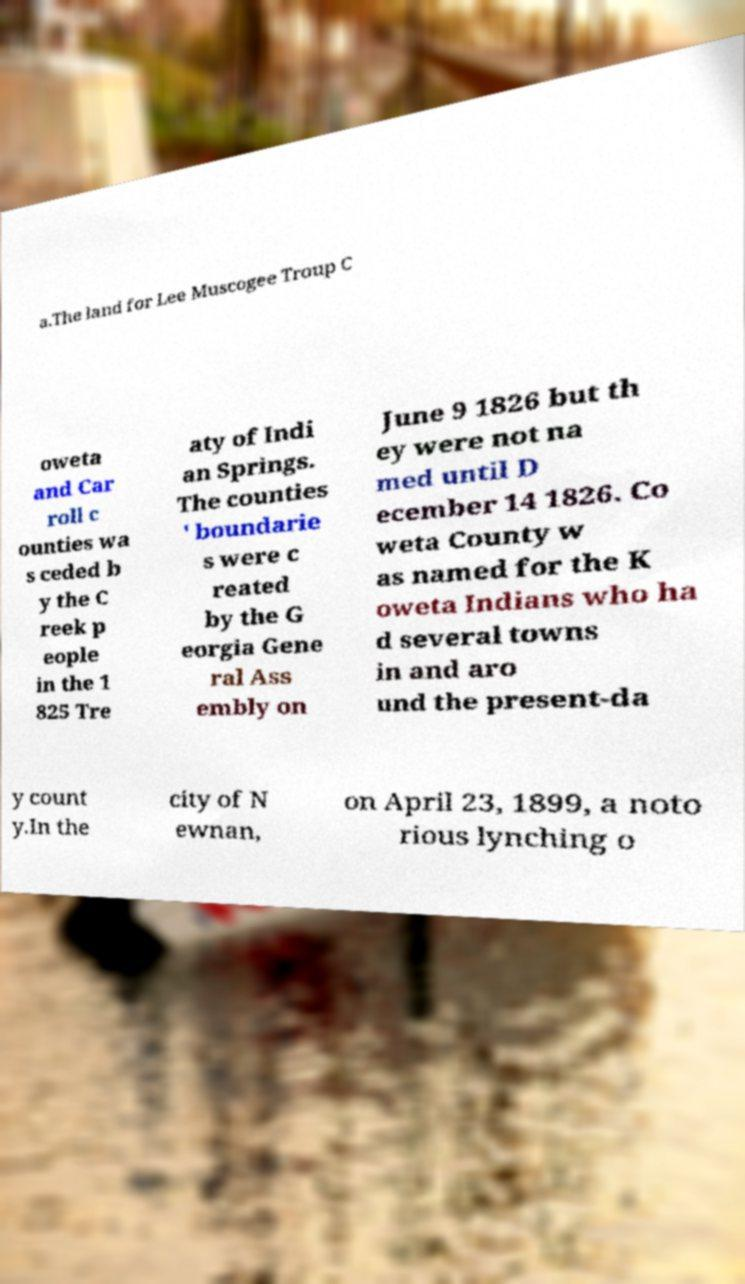I need the written content from this picture converted into text. Can you do that? a.The land for Lee Muscogee Troup C oweta and Car roll c ounties wa s ceded b y the C reek p eople in the 1 825 Tre aty of Indi an Springs. The counties ' boundarie s were c reated by the G eorgia Gene ral Ass embly on June 9 1826 but th ey were not na med until D ecember 14 1826. Co weta County w as named for the K oweta Indians who ha d several towns in and aro und the present-da y count y.In the city of N ewnan, on April 23, 1899, a noto rious lynching o 